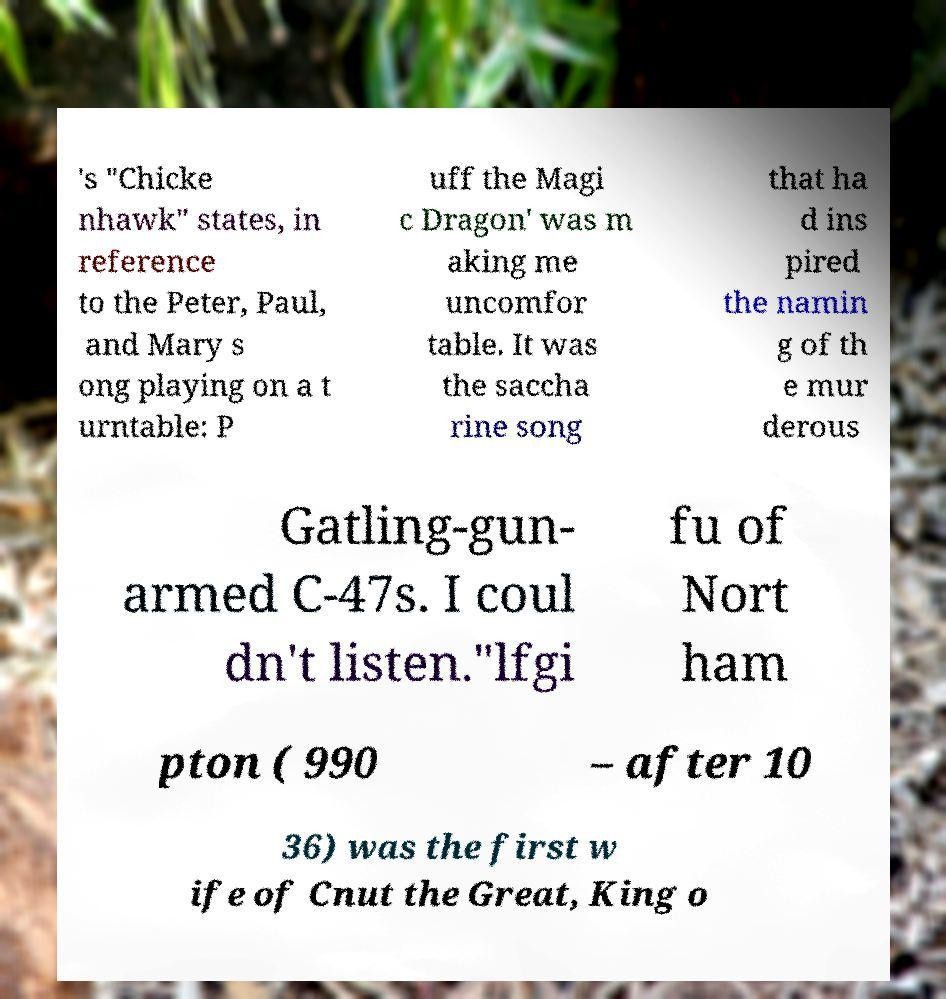There's text embedded in this image that I need extracted. Can you transcribe it verbatim? 's "Chicke nhawk" states, in reference to the Peter, Paul, and Mary s ong playing on a t urntable: P uff the Magi c Dragon' was m aking me uncomfor table. It was the saccha rine song that ha d ins pired the namin g of th e mur derous Gatling-gun- armed C-47s. I coul dn't listen."lfgi fu of Nort ham pton ( 990 – after 10 36) was the first w ife of Cnut the Great, King o 